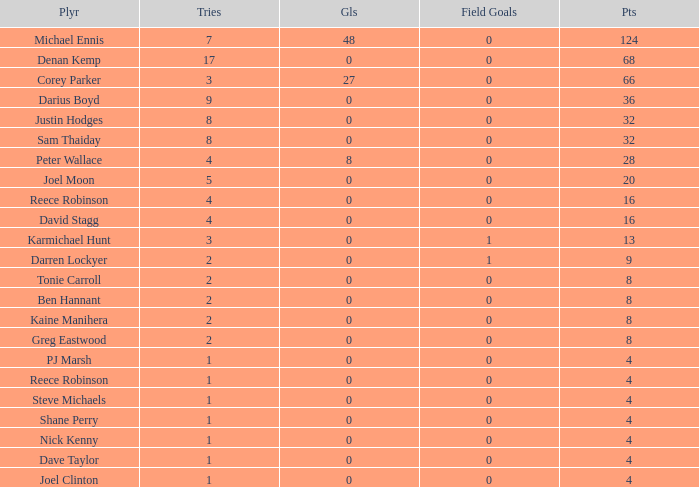How many goals did the player with less than 4 points have? 0.0. 